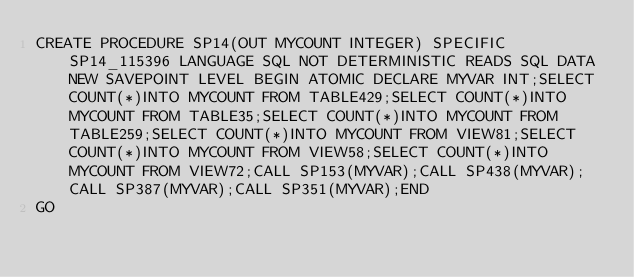<code> <loc_0><loc_0><loc_500><loc_500><_SQL_>CREATE PROCEDURE SP14(OUT MYCOUNT INTEGER) SPECIFIC SP14_115396 LANGUAGE SQL NOT DETERMINISTIC READS SQL DATA NEW SAVEPOINT LEVEL BEGIN ATOMIC DECLARE MYVAR INT;SELECT COUNT(*)INTO MYCOUNT FROM TABLE429;SELECT COUNT(*)INTO MYCOUNT FROM TABLE35;SELECT COUNT(*)INTO MYCOUNT FROM TABLE259;SELECT COUNT(*)INTO MYCOUNT FROM VIEW81;SELECT COUNT(*)INTO MYCOUNT FROM VIEW58;SELECT COUNT(*)INTO MYCOUNT FROM VIEW72;CALL SP153(MYVAR);CALL SP438(MYVAR);CALL SP387(MYVAR);CALL SP351(MYVAR);END
GO</code> 